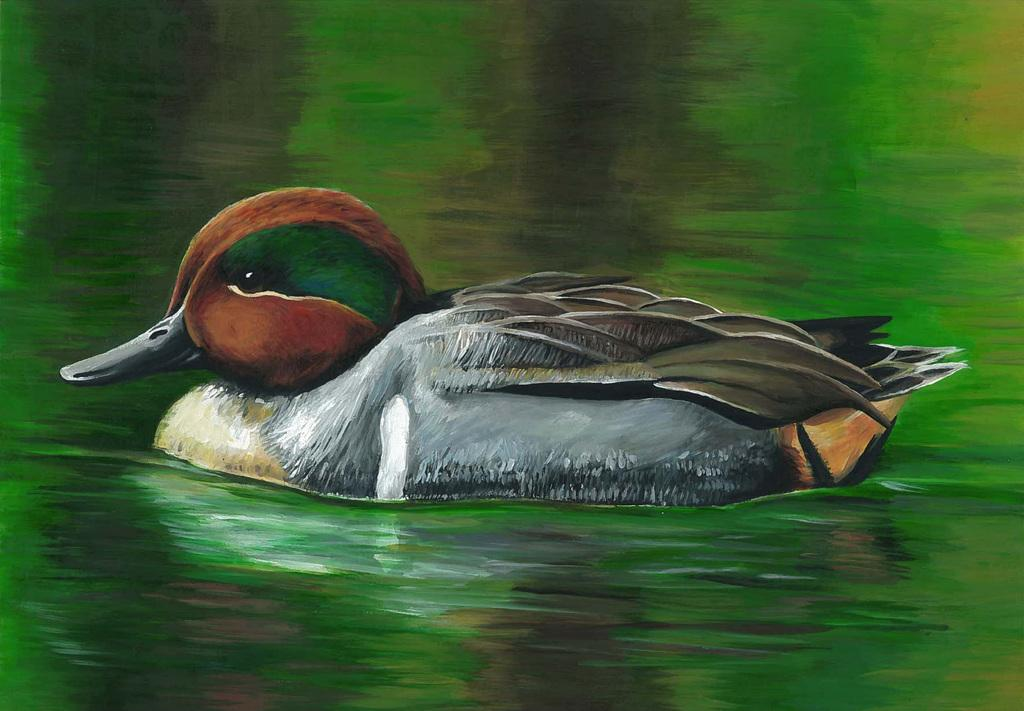What is depicted in the picture within the image? There is a painting in the image. What type of animal can be seen in the image? There is a bird in the image. Where is the bird located in the image? The bird is on the water. What is the size of the bird's act in the image? There is no act or behavior performed by the bird in the image, and therefore no size can be determined. 